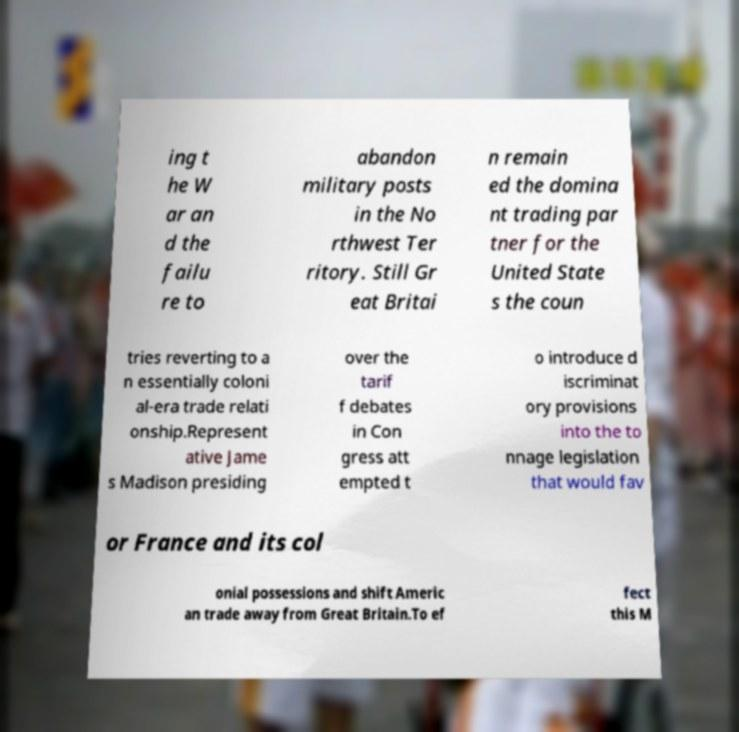For documentation purposes, I need the text within this image transcribed. Could you provide that? ing t he W ar an d the failu re to abandon military posts in the No rthwest Ter ritory. Still Gr eat Britai n remain ed the domina nt trading par tner for the United State s the coun tries reverting to a n essentially coloni al-era trade relati onship.Represent ative Jame s Madison presiding over the tarif f debates in Con gress att empted t o introduce d iscriminat ory provisions into the to nnage legislation that would fav or France and its col onial possessions and shift Americ an trade away from Great Britain.To ef fect this M 